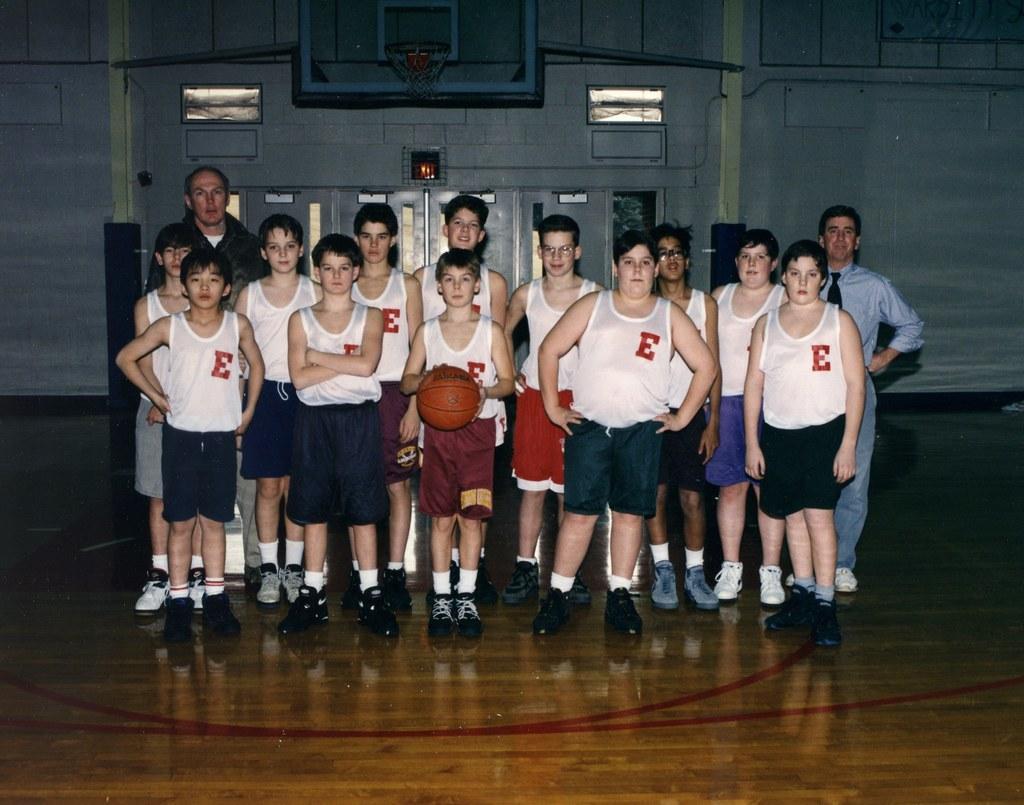How would you summarize this image in a sentence or two? In this picture I see number of boys and 2 men who are standing in front and I see that this boy who is in the middle of this picture is holding the ball and I see the court. In the background I see the basket and I see the wall. 